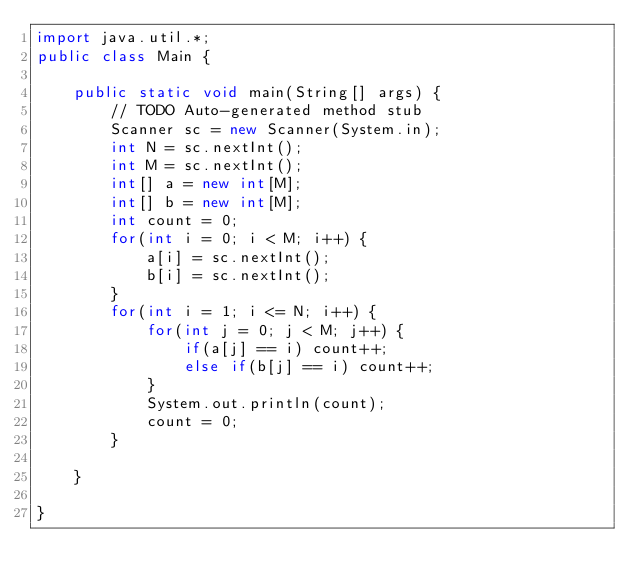Convert code to text. <code><loc_0><loc_0><loc_500><loc_500><_Java_>import java.util.*;
public class Main {

	public static void main(String[] args) {
		// TODO Auto-generated method stub
		Scanner sc = new Scanner(System.in);
		int N = sc.nextInt();
		int M = sc.nextInt();
		int[] a = new int[M];
		int[] b = new int[M];
		int count = 0;
		for(int i = 0; i < M; i++) {
			a[i] = sc.nextInt();
			b[i] = sc.nextInt();
		}
		for(int i = 1; i <= N; i++) {
			for(int j = 0; j < M; j++) {
				if(a[j] == i) count++;
				else if(b[j] == i) count++;
			}
			System.out.println(count);
			count = 0;
		}

	}

}</code> 